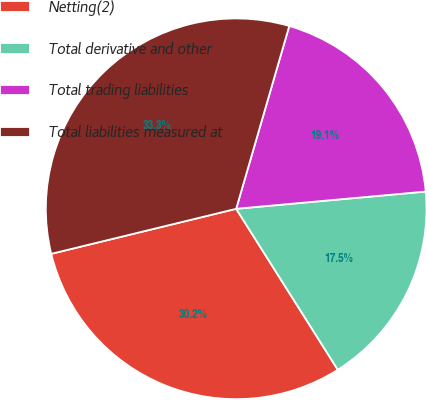<chart> <loc_0><loc_0><loc_500><loc_500><pie_chart><fcel>Netting(2)<fcel>Total derivative and other<fcel>Total trading liabilities<fcel>Total liabilities measured at<nl><fcel>30.16%<fcel>17.48%<fcel>19.06%<fcel>33.3%<nl></chart> 